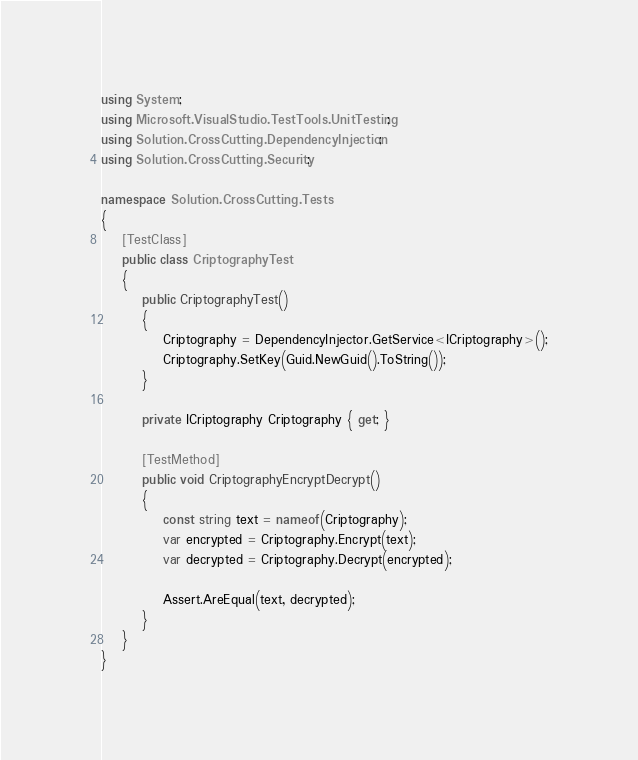<code> <loc_0><loc_0><loc_500><loc_500><_C#_>using System;
using Microsoft.VisualStudio.TestTools.UnitTesting;
using Solution.CrossCutting.DependencyInjection;
using Solution.CrossCutting.Security;

namespace Solution.CrossCutting.Tests
{
    [TestClass]
    public class CriptographyTest
    {
        public CriptographyTest()
        {
            Criptography = DependencyInjector.GetService<ICriptography>();
            Criptography.SetKey(Guid.NewGuid().ToString());
        }

        private ICriptography Criptography { get; }

        [TestMethod]
        public void CriptographyEncryptDecrypt()
        {
            const string text = nameof(Criptography);
            var encrypted = Criptography.Encrypt(text);
            var decrypted = Criptography.Decrypt(encrypted);

            Assert.AreEqual(text, decrypted);
        }
    }
}
</code> 